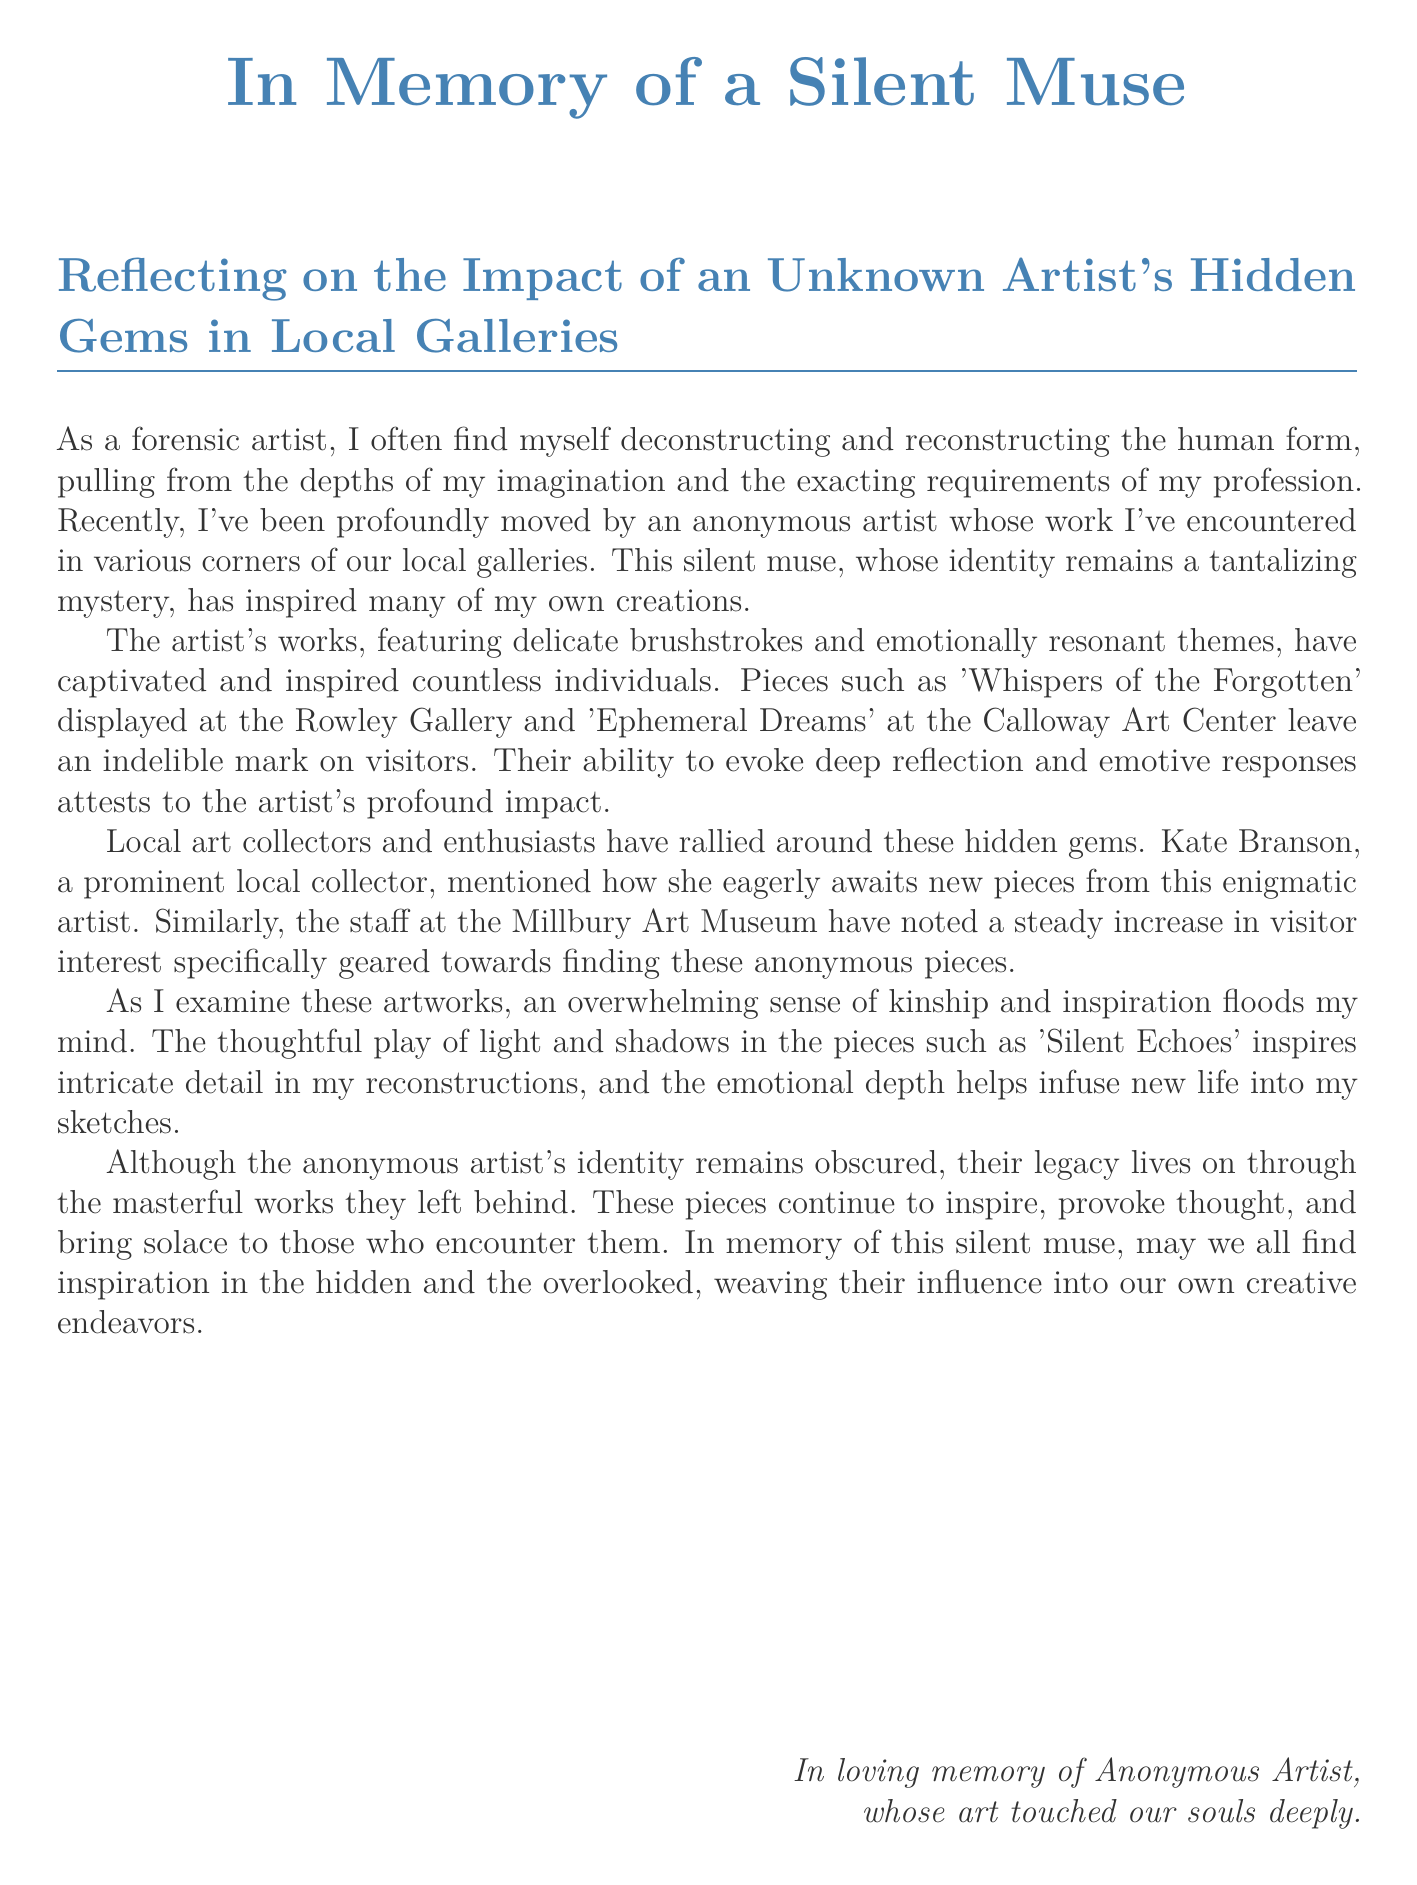What is the title of the document? The title is presented prominently at the start of the document.
Answer: In Memory of a Silent Muse Who is the anonymous artist referenced in the document? The document uses the term "Anonymous Artist" to refer to the individual.
Answer: Anonymous Artist What is one of the artworks displayed at the Rowley Gallery? The document mentions specific artworks associated with the anonymous artist, one of which appears at the Rowley Gallery.
Answer: Whispers of the Forgotten What is the name of the local collector mentioned in the document? The document specifies a prominent local collector who appreciates the anonymous artist's work.
Answer: Kate Branson Which gallery has noted an increase in visitor interest in the anonymous artist's pieces? The document refers to a specific museum observing an uptick in visitor interest.
Answer: Millbury Art Museum What emotion does the anonymous artist's work generally evoke? The document describes the emotional impact of the artworks on visitors.
Answer: Reflection How does the forensic artist describe their process? The artist describes a specific method they utilize in their work.
Answer: Deconstructing and reconstructing What type of legacy does the anonymous artist leave behind? The document highlights the enduring impact of the artist's creations even in their anonymity.
Answer: Legacy of inspiration 